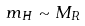Convert formula to latex. <formula><loc_0><loc_0><loc_500><loc_500>m _ { H } \sim M _ { R }</formula> 